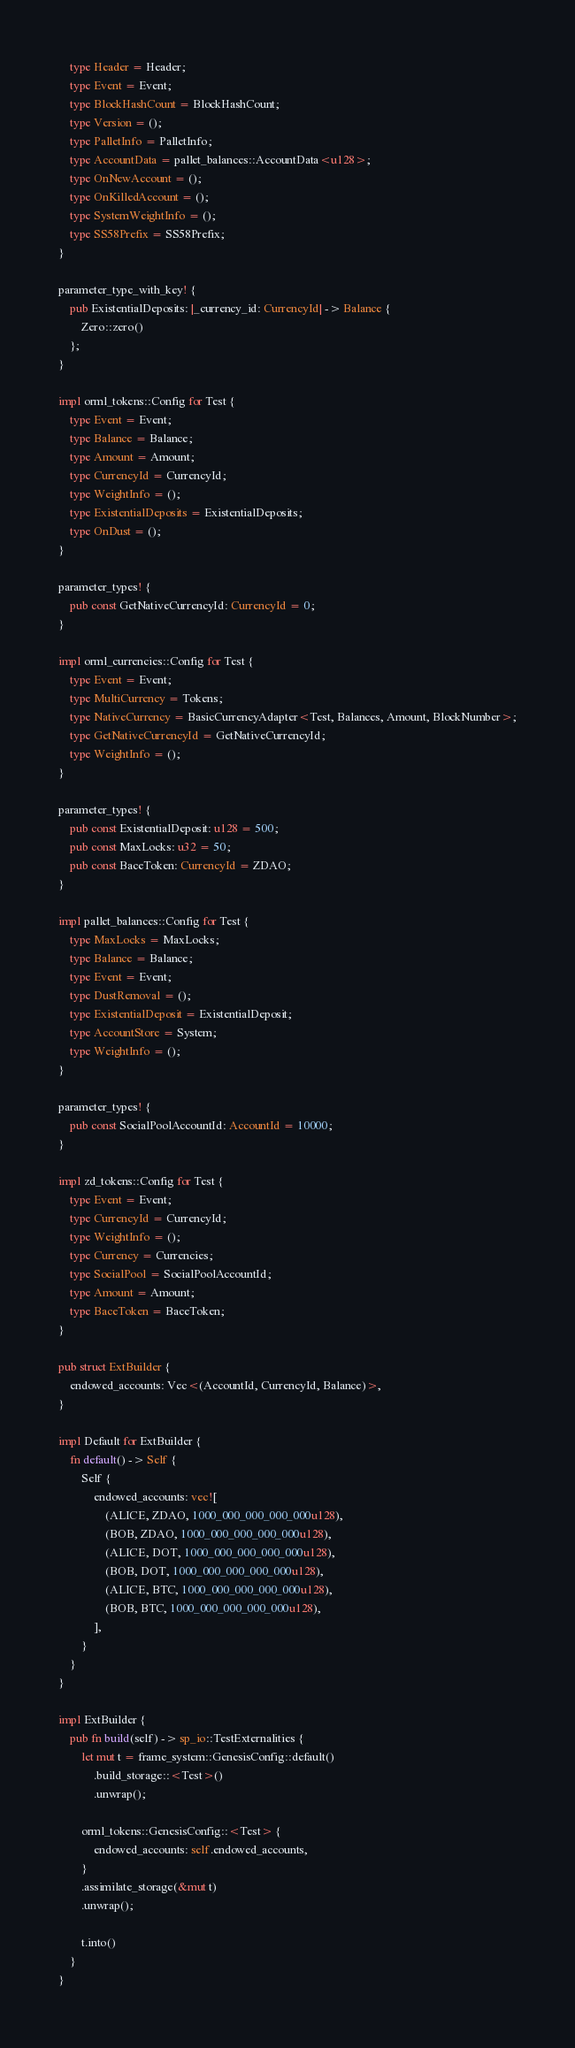Convert code to text. <code><loc_0><loc_0><loc_500><loc_500><_Rust_>    type Header = Header;
    type Event = Event;
    type BlockHashCount = BlockHashCount;
    type Version = ();
    type PalletInfo = PalletInfo;
    type AccountData = pallet_balances::AccountData<u128>;
    type OnNewAccount = ();
    type OnKilledAccount = ();
    type SystemWeightInfo = ();
    type SS58Prefix = SS58Prefix;
}

parameter_type_with_key! {
    pub ExistentialDeposits: |_currency_id: CurrencyId| -> Balance {
        Zero::zero()
    };
}

impl orml_tokens::Config for Test {
    type Event = Event;
    type Balance = Balance;
    type Amount = Amount;
    type CurrencyId = CurrencyId;
    type WeightInfo = ();
    type ExistentialDeposits = ExistentialDeposits;
    type OnDust = ();
}

parameter_types! {
    pub const GetNativeCurrencyId: CurrencyId = 0;
}

impl orml_currencies::Config for Test {
    type Event = Event;
    type MultiCurrency = Tokens;
    type NativeCurrency = BasicCurrencyAdapter<Test, Balances, Amount, BlockNumber>;
    type GetNativeCurrencyId = GetNativeCurrencyId;
    type WeightInfo = ();
}

parameter_types! {
    pub const ExistentialDeposit: u128 = 500;
    pub const MaxLocks: u32 = 50;
    pub const BaceToken: CurrencyId = ZDAO;
}

impl pallet_balances::Config for Test {
    type MaxLocks = MaxLocks;
    type Balance = Balance;
    type Event = Event;
    type DustRemoval = ();
    type ExistentialDeposit = ExistentialDeposit;
    type AccountStore = System;
    type WeightInfo = ();
}

parameter_types! {
    pub const SocialPoolAccountId: AccountId = 10000;
}

impl zd_tokens::Config for Test {
    type Event = Event;
    type CurrencyId = CurrencyId;
    type WeightInfo = ();
    type Currency = Currencies;
    type SocialPool = SocialPoolAccountId;
    type Amount = Amount;
    type BaceToken = BaceToken;
}

pub struct ExtBuilder {
    endowed_accounts: Vec<(AccountId, CurrencyId, Balance)>,
}

impl Default for ExtBuilder {
    fn default() -> Self {
        Self {
            endowed_accounts: vec![
                (ALICE, ZDAO, 1000_000_000_000_000u128),
                (BOB, ZDAO, 1000_000_000_000_000u128),
                (ALICE, DOT, 1000_000_000_000_000u128),
                (BOB, DOT, 1000_000_000_000_000u128),
                (ALICE, BTC, 1000_000_000_000_000u128),
                (BOB, BTC, 1000_000_000_000_000u128),
            ],
        }
    }
}

impl ExtBuilder {
    pub fn build(self) -> sp_io::TestExternalities {
        let mut t = frame_system::GenesisConfig::default()
            .build_storage::<Test>()
            .unwrap();

        orml_tokens::GenesisConfig::<Test> {
            endowed_accounts: self.endowed_accounts,
        }
        .assimilate_storage(&mut t)
        .unwrap();

        t.into()
    }
}</code> 